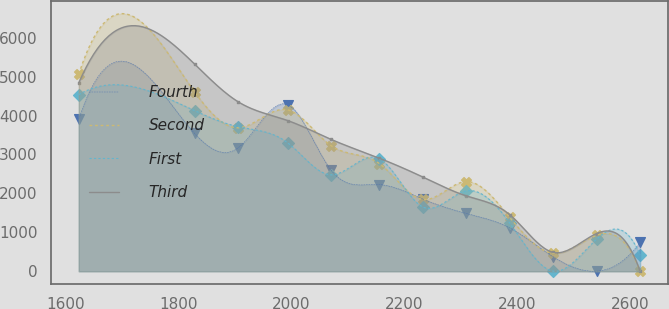Convert chart to OTSL. <chart><loc_0><loc_0><loc_500><loc_500><line_chart><ecel><fcel>Fourth<fcel>Second<fcel>First<fcel>Third<nl><fcel>1624.1<fcel>3911.64<fcel>5069.4<fcel>4540.4<fcel>4840.97<nl><fcel>1828.99<fcel>3540.58<fcel>4608.65<fcel>4127.72<fcel>5324.96<nl><fcel>1905.9<fcel>3169.52<fcel>3687.15<fcel>3715.04<fcel>4356.98<nl><fcel>1993.65<fcel>4282.7<fcel>4147.9<fcel>3302.36<fcel>3872.99<nl><fcel>2070.56<fcel>2598.34<fcel>3226.4<fcel>2477<fcel>3389<nl><fcel>2156.05<fcel>2227.28<fcel>2765.65<fcel>2889.68<fcel>2905.01<nl><fcel>2232.96<fcel>1856.22<fcel>1844.15<fcel>1651.64<fcel>2421.02<nl><fcel>2309.87<fcel>1485.16<fcel>2304.9<fcel>2064.32<fcel>1937.03<nl><fcel>2386.78<fcel>1114.1<fcel>1383.4<fcel>1238.96<fcel>1453.04<nl><fcel>2463.69<fcel>371.98<fcel>461.9<fcel>0.92<fcel>485.06<nl><fcel>2540.6<fcel>0.92<fcel>922.65<fcel>826.28<fcel>969.05<nl><fcel>2617.51<fcel>743.04<fcel>1.15<fcel>413.6<fcel>1.07<nl></chart> 